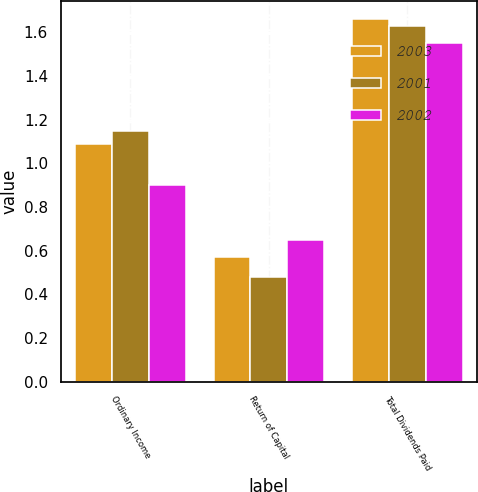Convert chart to OTSL. <chart><loc_0><loc_0><loc_500><loc_500><stacked_bar_chart><ecel><fcel>Ordinary Income<fcel>Return of Capital<fcel>Total Dividends Paid<nl><fcel>2003<fcel>1.09<fcel>0.57<fcel>1.66<nl><fcel>2001<fcel>1.15<fcel>0.48<fcel>1.63<nl><fcel>2002<fcel>0.9<fcel>0.65<fcel>1.55<nl></chart> 